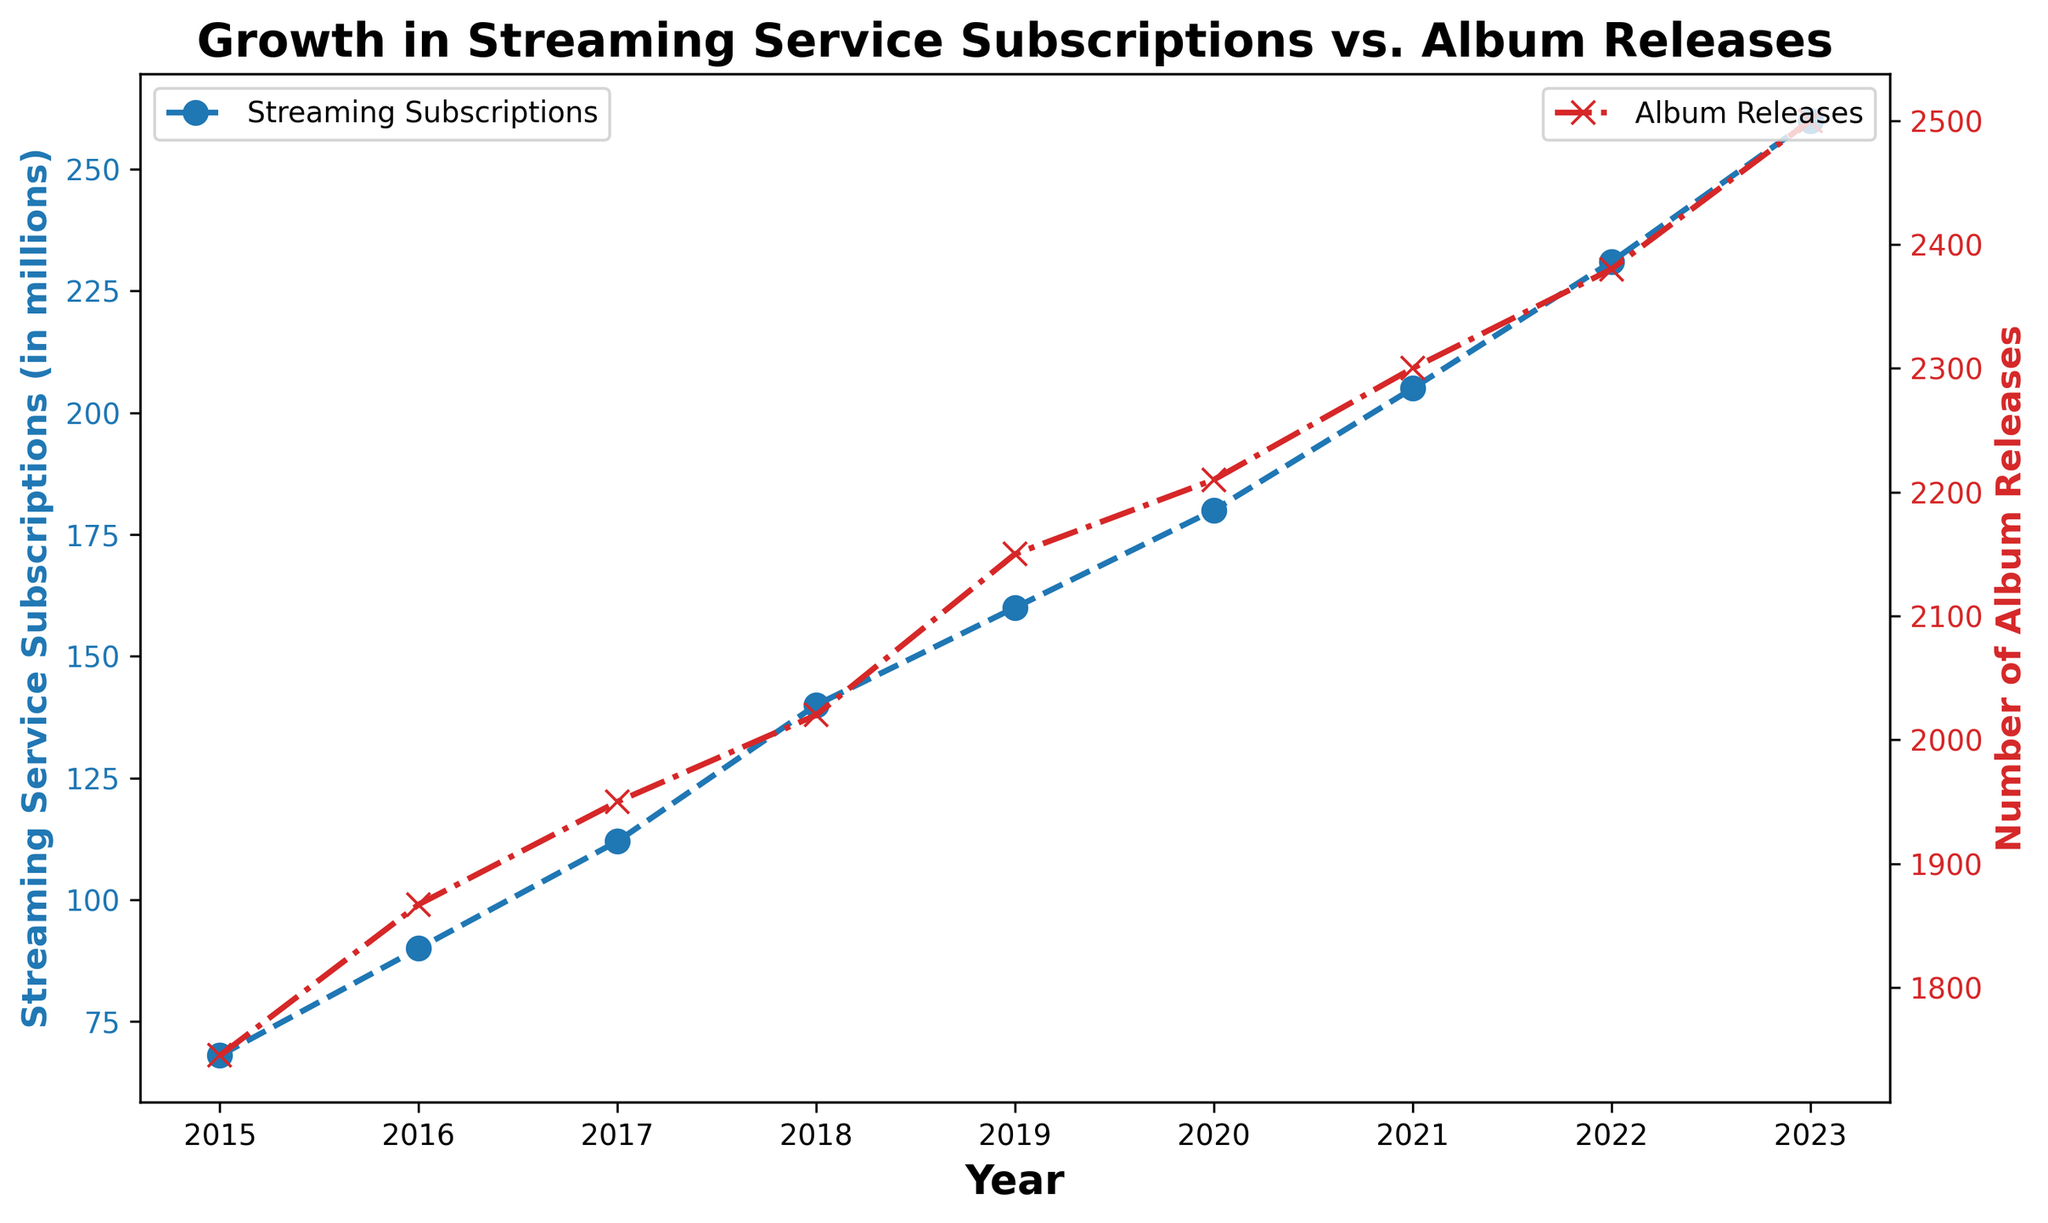What's the increase in streaming subscriptions between 2015 and 2023? The number of streaming subscriptions in 2015 is 68 million and in 2023 is 260 million. The increase is calculated as 260 - 68.
Answer: 192 million How many more albums were released in 2023 compared to 2015? The number of album releases in 2015 is 1745 and in 2023 is 2500. The difference is calculated as 2500 - 1745.
Answer: 755 In which year did streaming subscriptions see the greatest increase? By comparing the increases year-over-year from the plot, the largest increase can be observed visually. The greatest increase occurred between 2022 (231 million) and 2023 (260 million), which is 29 million.
Answer: 2022 to 2023 Did the number of album releases increase every year from 2015 to 2023? By visually examining the plotting line for album releases, we see that it continuously ascends without any dips.
Answer: Yes What is the average number of album releases between 2018 and 2023? The number of album releases each year from 2018 to 2023 are 2020, 2150, 2210, 2300, 2380, and 2500 respectively. Summing those gives a total of 13,560. The number of years is 6. So, the average is 13,560 / 6.
Answer: 2260 Which year had the highest number of album releases? Visually, the highest point on the red dashed line corresponding to album releases is at the year 2023.
Answer: 2023 What can be said about the trend in streaming service subscriptions from 2015 to 2023? Visualizing the blue line, it shows a rapidly increasing trend from 2015 to 2023.
Answer: Increasing By how much did the album releases increase from 2016 to 2017? The number of album releases in 2016 is 1867 and in 2017 is 1950. The increase is 1950 - 1867.
Answer: 83 Are the trends in streaming subscriptions and album releases correlated? Both lines on the plot show a positive increase, suggesting that as the number of streaming subscriptions increases, so does the number of album releases.
Answer: Yes In which year did both streaming subscriptions and album releases cross 200 for the first time? Streaming subscriptions surpassed 200 million and album releases surpassed 2000 in 2020 as seen on the plot.
Answer: 2020 